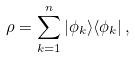<formula> <loc_0><loc_0><loc_500><loc_500>\rho = \sum _ { k = 1 } ^ { n } | \phi _ { k } \rangle \langle \phi _ { k } | \, ,</formula> 